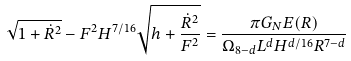<formula> <loc_0><loc_0><loc_500><loc_500>\sqrt { 1 + { \dot { R } ^ { 2 } } } - F ^ { 2 } H ^ { 7 / 1 6 } \sqrt { h + \frac { { \dot { R } } ^ { 2 } } { F ^ { 2 } } } = \frac { \pi G _ { N } E ( R ) } { \Omega _ { 8 - d } L ^ { d } H ^ { d / 1 6 } R ^ { 7 - d } }</formula> 